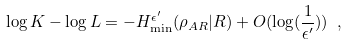<formula> <loc_0><loc_0><loc_500><loc_500>\log { K } - \log { L } = - H _ { \min } ^ { \epsilon ^ { \prime } } ( \rho _ { A R } | R ) + O ( \log ( \frac { 1 } { \epsilon ^ { \prime } } ) ) \ ,</formula> 